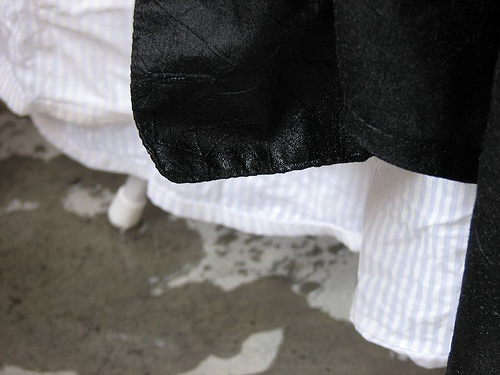<image>
Is the cloth next to the cloth? No. The cloth is not positioned next to the cloth. They are located in different areas of the scene. Is the black tissue in front of the white tissue? Yes. The black tissue is positioned in front of the white tissue, appearing closer to the camera viewpoint. 